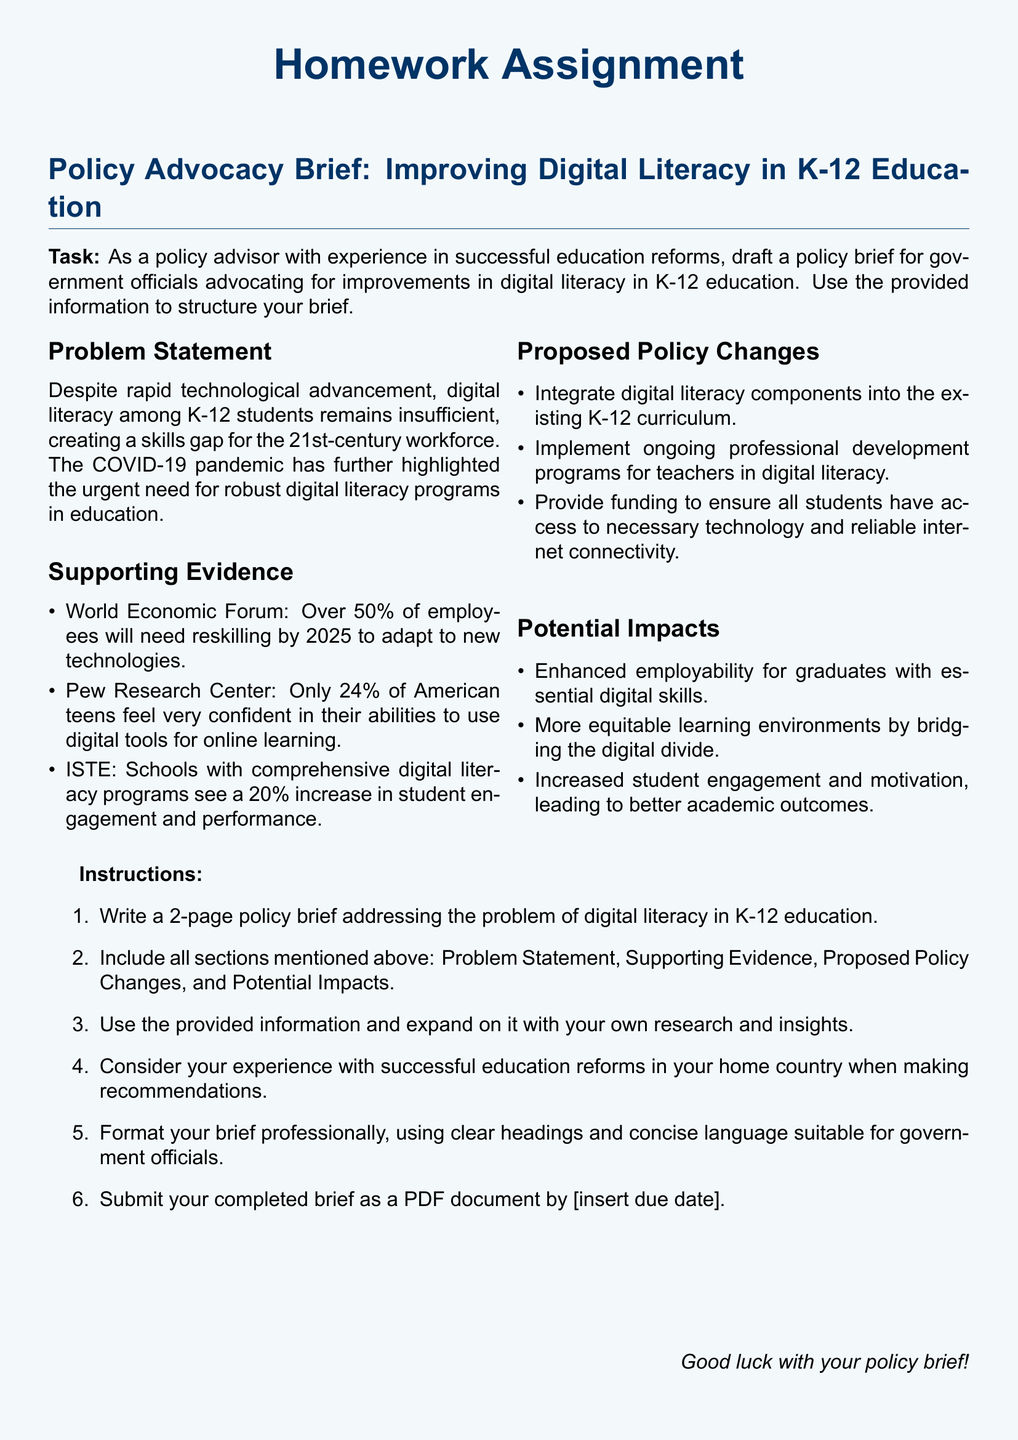What is the primary focus of the policy brief? The primary focus of the policy brief is improving digital literacy in K-12 education.
Answer: Improving digital literacy in K-12 education What percentage of employees will need reskilling by 2025? The document states that over 50% of employees will need reskilling by 2025.
Answer: 50% What is the percentage of American teens who feel confident in using digital tools for online learning? According to the Pew Research Center, only 24% of American teens feel very confident in their abilities.
Answer: 24% What is one proposed policy change regarding teachers? One proposed policy change is to implement ongoing professional development programs for teachers in digital literacy.
Answer: Ongoing professional development programs How many pages should the policy brief be? The assignment specifies that the policy brief should be 2 pages long.
Answer: 2 pages What impact does the document suggest digital literacy programs have on student engagement? The document mentions that schools with comprehensive digital literacy programs see a 20% increase in student engagement and performance.
Answer: 20% What is one potential impact of enhancing digital skills for graduates? Enhanced employability is one potential impact mentioned for graduates with essential digital skills.
Answer: Enhanced employability What should be included in the policy brief's structure? The policy brief should include Problem Statement, Supporting Evidence, Proposed Policy Changes, and Potential Impacts.
Answer: Problem Statement, Supporting Evidence, Proposed Policy Changes, and Potential Impacts 